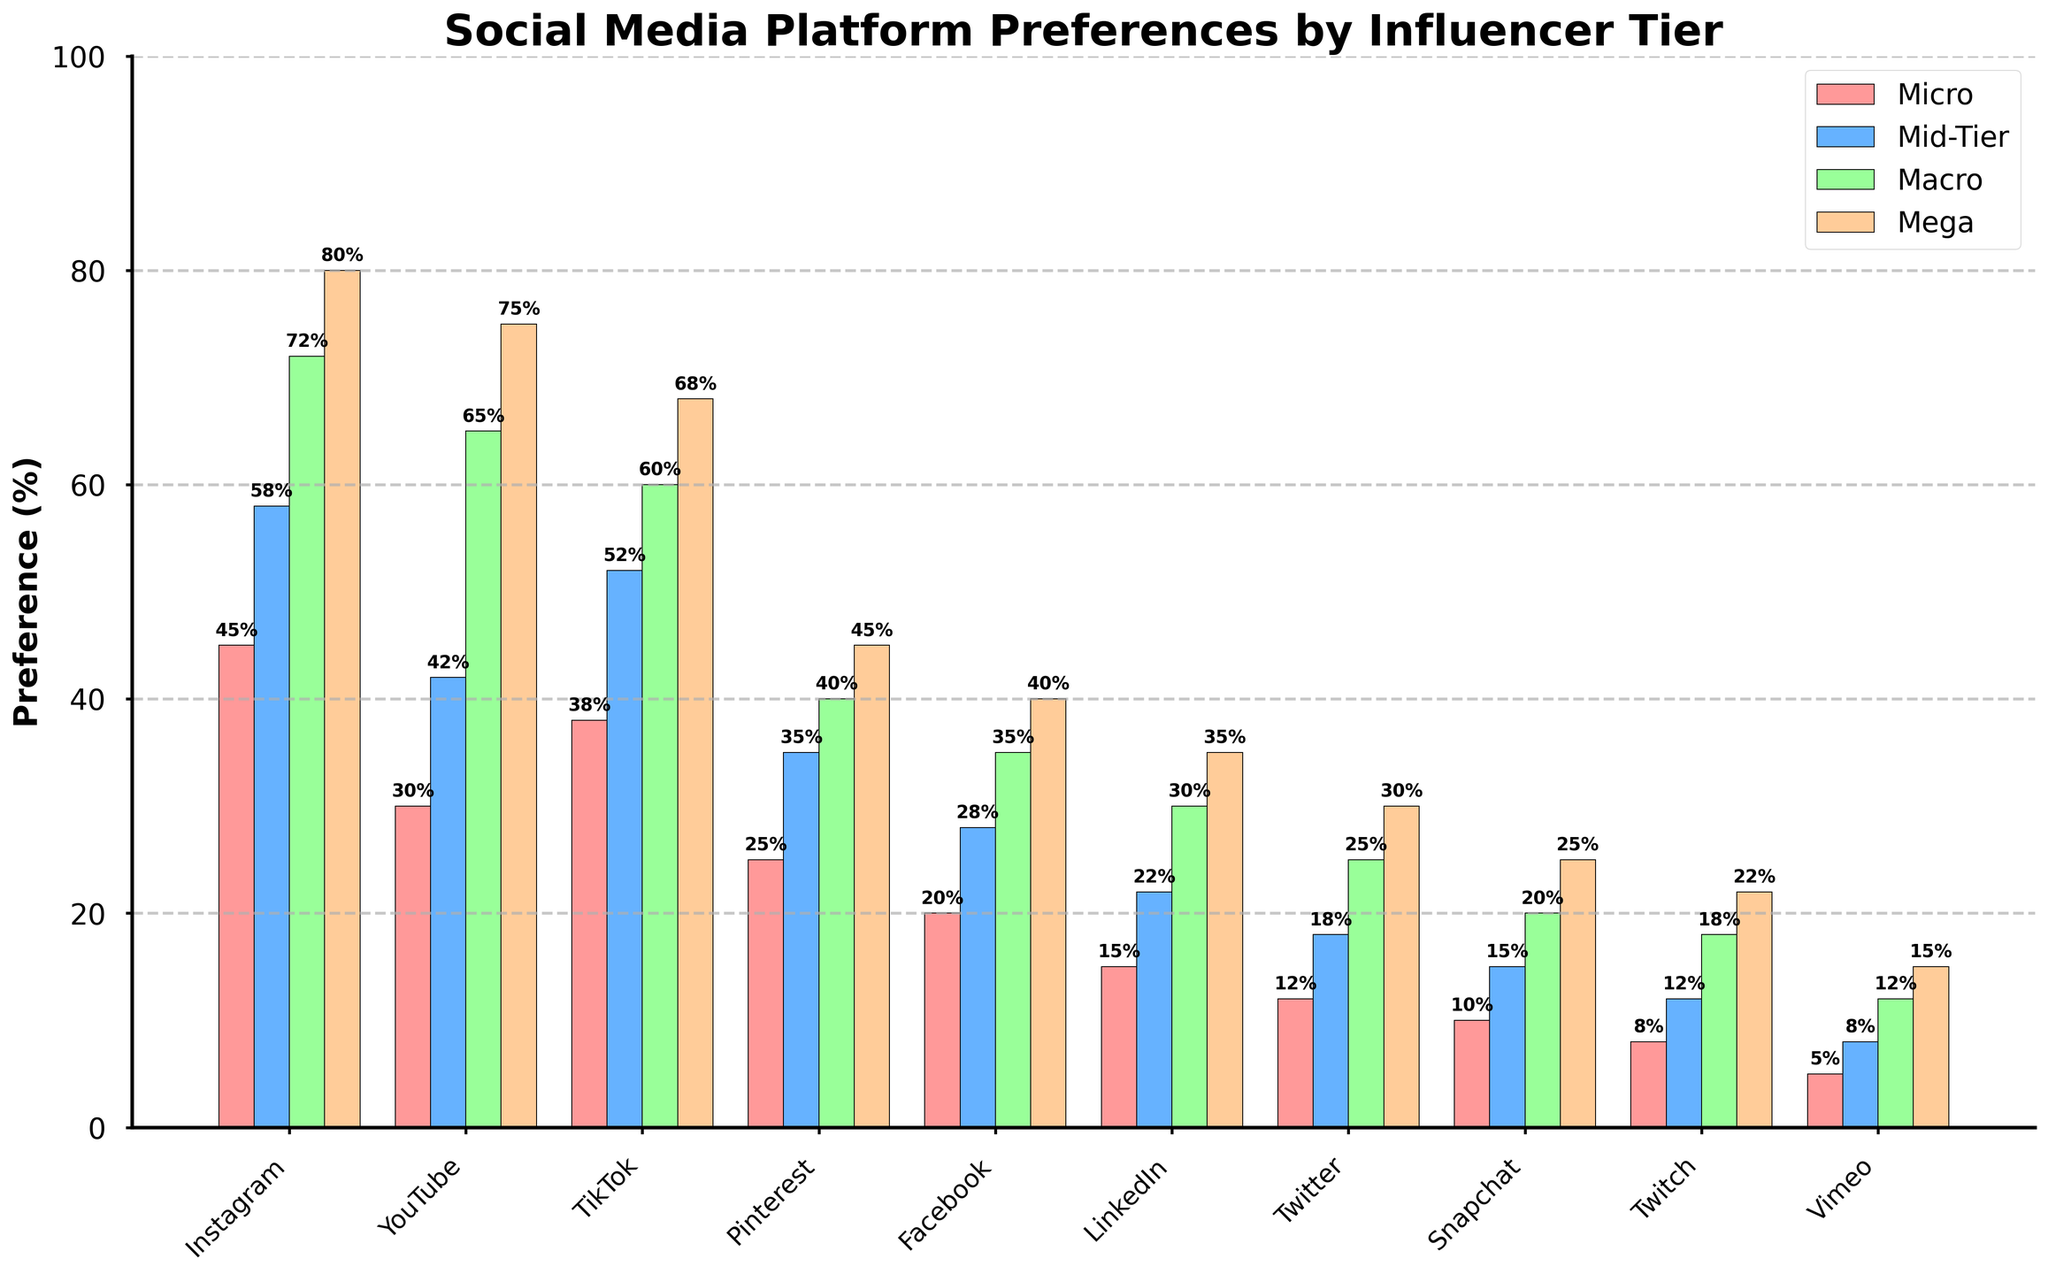What platform is least preferred by Mega-Influencers? Start by looking at the heights of the bars for Mega-Influencers across all platforms. The shortest bar represents the least preferred platform. Vimeo has the smallest value at 15.
Answer: Vimeo Which platform shows the largest preference increase from Micro to Mega-Influencers? Calculate the difference between Mega-Influencers and Micro-Influencers for each platform. The platform with the highest difference indicates the largest increase. Instagram increases from 45 to 80, which is a difference of 35.
Answer: Instagram Among the Mid-Tier Influencers, which two platforms have the closest preference levels? Compare the bar heights for all platforms in the Mid-Tier Influencers category to find the two with the smallest difference. Pinterest and Facebook have values of 35 and 28, respectively, giving a difference of 7.
Answer: Pinterest and Facebook On which platforms do Macro-Influencers show more preference than YouTube? Compare the height of the YouTube bar in the Macro-Influencers group to those of other platforms in the same group. Values greater than YouTube's 65 are Instagram at 72 and TikTok at 60. Only Instagram exceeds YouTube.
Answer: Instagram What's the average preference percentage of TikTok across all influencer tiers? Compute the average by summing the percentages of TikTok for Micro (38), Mid-Tier (52), Macro (60), and Mega (68) influencers, and then divide by the number of tiers. (38 + 52 + 60 + 68) / 4 = 54.5%
Answer: 54.5% Which platform is equally preferred by both Macro and Mega-Influencers? Examine the bar heights for Macro and Mega-Influencers to find any platform where the preference percentages are equal. All platforms should be checked, but here, Pinterest has preference percentages of 40 each.
Answer: Pinterest What is the total preference percentage of Snapchat across all influencer tiers? Add the preference percentages for Snapchat for Micro (10), Mid-Tier (15), Macro (20), and Mega (25) influencers. 10 + 15 + 20 + 25 = 70%
Answer: 70% Which influencer tier shows the widest range of preferences across the platforms? Calculate the range for each tier by subtracting the smallest percentage value from the largest for each tier. The largest range among: Micro (45 - 5), Mid-Tier (58 - 8), Macro (72 - 12), and Mega (80 - 15). Micro has the largest range, 45 - 5 = 40.
Answer: Micro Where do Micro and Mid-Tier Influencers show the same preference level? Compare the heights of bars corresponding to Micro and Mid-Tier Influencers to find any platform where the preferences are equal. No such platform exists in this dataset.
Answer: None 